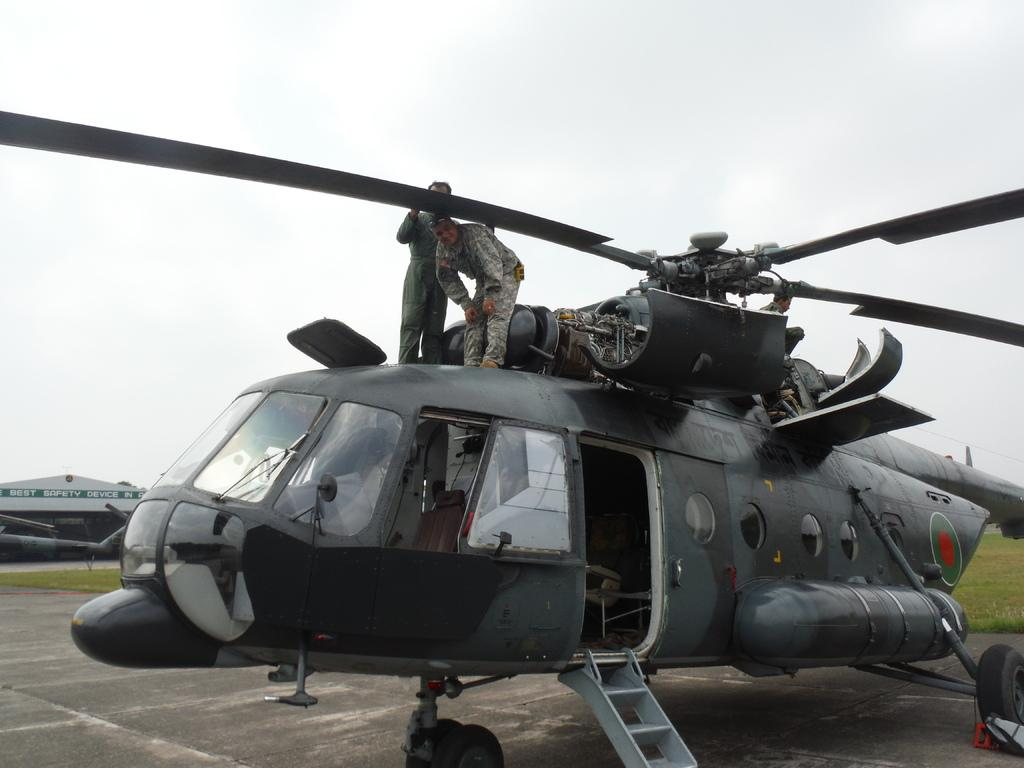How many people are in the image? There are two people in the image. What else can be seen in the image besides the people? There is a plane and grass visible in the image. What is visible at the top of the image? The sky is visible at the top of the image. What type of seat is visible in the image? There is no seat present in the image. Can you describe the veins in the grass in the image? There are no veins visible in the grass in the image; it is a general representation of grass. 